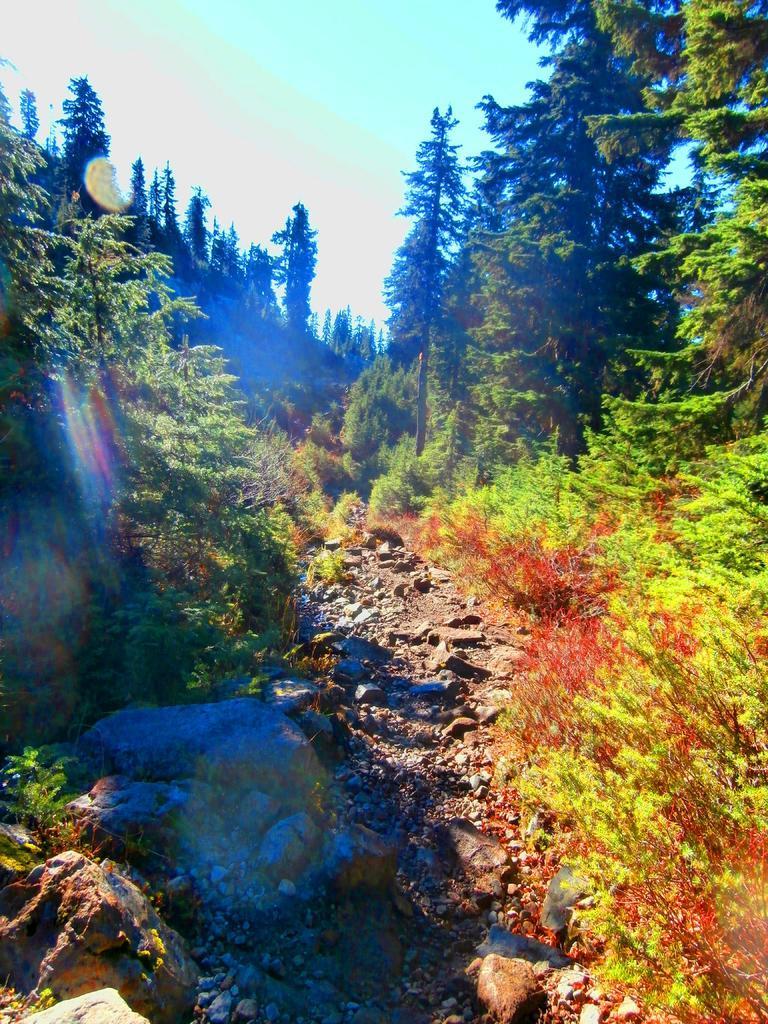Could you give a brief overview of what you see in this image? In this image we can see trees, stones and sky. 